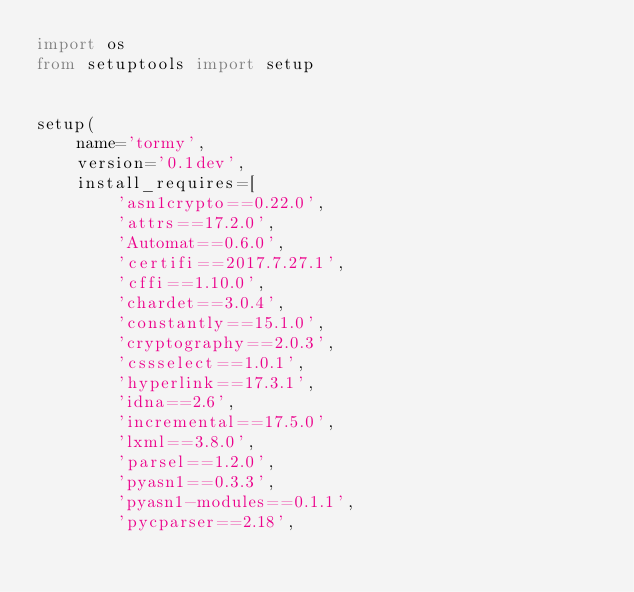<code> <loc_0><loc_0><loc_500><loc_500><_Python_>import os
from setuptools import setup


setup(
    name='tormy',
    version='0.1dev',
    install_requires=[
        'asn1crypto==0.22.0',
        'attrs==17.2.0',
        'Automat==0.6.0',
        'certifi==2017.7.27.1',
        'cffi==1.10.0',
        'chardet==3.0.4',
        'constantly==15.1.0',
        'cryptography==2.0.3',
        'cssselect==1.0.1',
        'hyperlink==17.3.1',
        'idna==2.6',
        'incremental==17.5.0',
        'lxml==3.8.0',
        'parsel==1.2.0',
        'pyasn1==0.3.3',
        'pyasn1-modules==0.1.1',
        'pycparser==2.18',</code> 